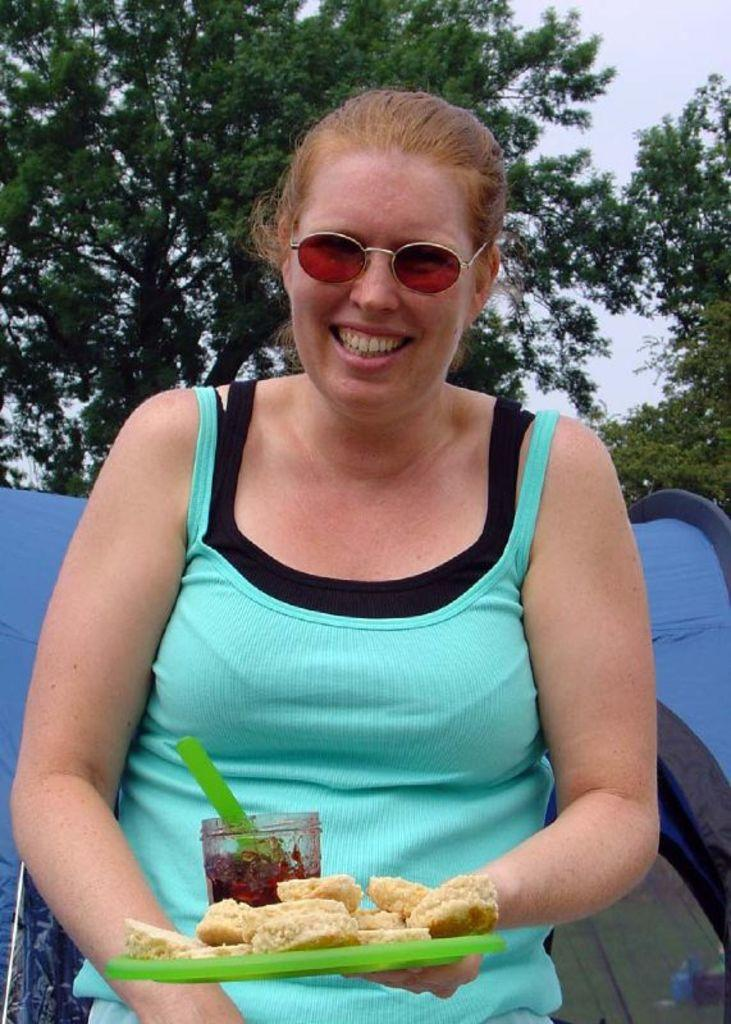Who is present in the image? There is a woman in the image. What is the woman wearing? The woman is wearing a green top. What is the woman holding in the image? The woman is holding a food item. What can be seen in the background of the image? There is a blue object, trees, and the sky visible in the background of the image. What type of car is parked next to the woman in the image? There is no car present in the image; it only features a woman, a food item, and the background elements. 